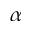Convert formula to latex. <formula><loc_0><loc_0><loc_500><loc_500>\alpha</formula> 